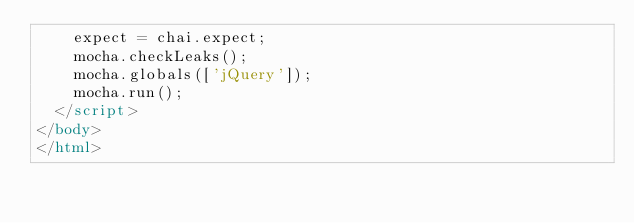<code> <loc_0><loc_0><loc_500><loc_500><_HTML_>    expect = chai.expect;
    mocha.checkLeaks();
    mocha.globals(['jQuery']);
    mocha.run();
  </script>
</body>
</html>
</code> 